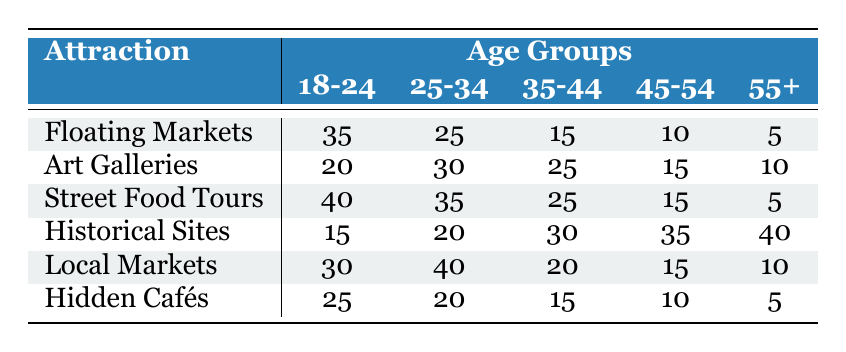What is the preference for Street Food Tours among the 18-24 age group? According to the table, the value for Street Food Tours under the 18-24 age group is 40.
Answer: 40 Which group has the highest interest in Historical Sites? The highest value in the Historical Sites row is 40, which corresponds to the 55+ age group.
Answer: 55+ How many people in the 25-34 age group prefer Local Markets compared to Hidden Cafés? The preference for Local Markets in the 25-34 age group is 40, and for Hidden Cafés, it is 20. The difference is 40 - 20 = 20.
Answer: 20 Is the preference for Floating Markets increasing with age? The preferences for Floating Markets are 35, 25, 15, 10, and 5 for the age groups 18-24 to 55+. This shows a decreasing trend with age.
Answer: No What is the average preference for Art Galleries across all age groups? The values for Art Galleries across the age groups are 20, 30, 25, 15, and 10. The sum is 20 + 30 + 25 + 15 + 10 = 100. Dividing by 5 gives an average of 100/5 = 20.
Answer: 20 Among the 45-54 age group, how do preferences compare between Historical Sites and Floating Markets? The preference for Historical Sites in this group is 35 and for Floating Markets, it is 10. Thus, Historical Sites are preferred more by 35 - 10 = 25.
Answer: 25 